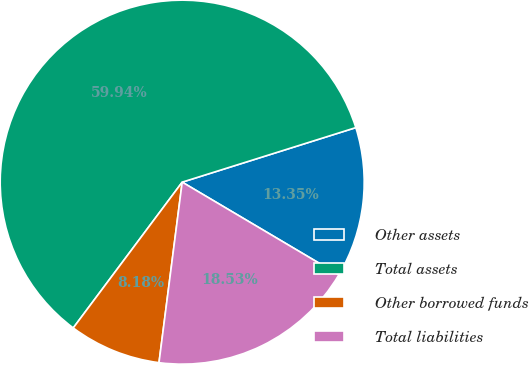Convert chart. <chart><loc_0><loc_0><loc_500><loc_500><pie_chart><fcel>Other assets<fcel>Total assets<fcel>Other borrowed funds<fcel>Total liabilities<nl><fcel>13.35%<fcel>59.94%<fcel>8.18%<fcel>18.53%<nl></chart> 